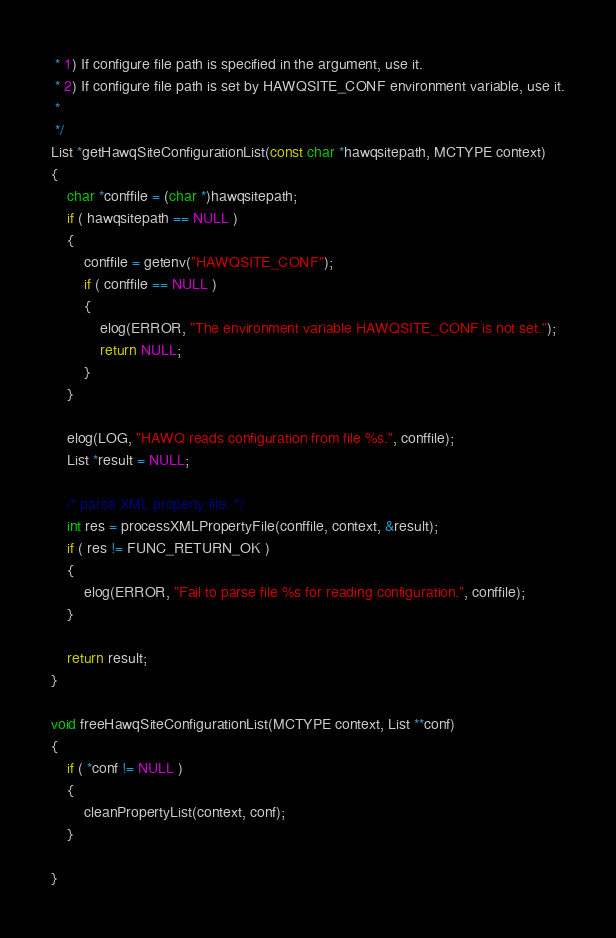Convert code to text. <code><loc_0><loc_0><loc_500><loc_500><_C_> * 1) If configure file path is specified in the argument, use it.
 * 2) If configure file path is set by HAWQSITE_CONF environment variable, use it.
 *
 */
List *getHawqSiteConfigurationList(const char *hawqsitepath, MCTYPE context)
{
	char *conffile = (char *)hawqsitepath;
	if ( hawqsitepath == NULL )
	{
		conffile = getenv("HAWQSITE_CONF");
		if ( conffile == NULL )
		{
			elog(ERROR, "The environment variable HAWQSITE_CONF is not set.");
			return NULL;
		}
	}

	elog(LOG, "HAWQ reads configuration from file %s.", conffile);
	List *result = NULL;

	/* parse XML property file. */
	int res = processXMLPropertyFile(conffile, context, &result);
	if ( res != FUNC_RETURN_OK )
	{
		elog(ERROR, "Fail to parse file %s for reading configuration.", conffile);
	}

	return result;
}

void freeHawqSiteConfigurationList(MCTYPE context, List **conf)
{
	if ( *conf != NULL )
	{
		cleanPropertyList(context, conf);
	}

}
</code> 